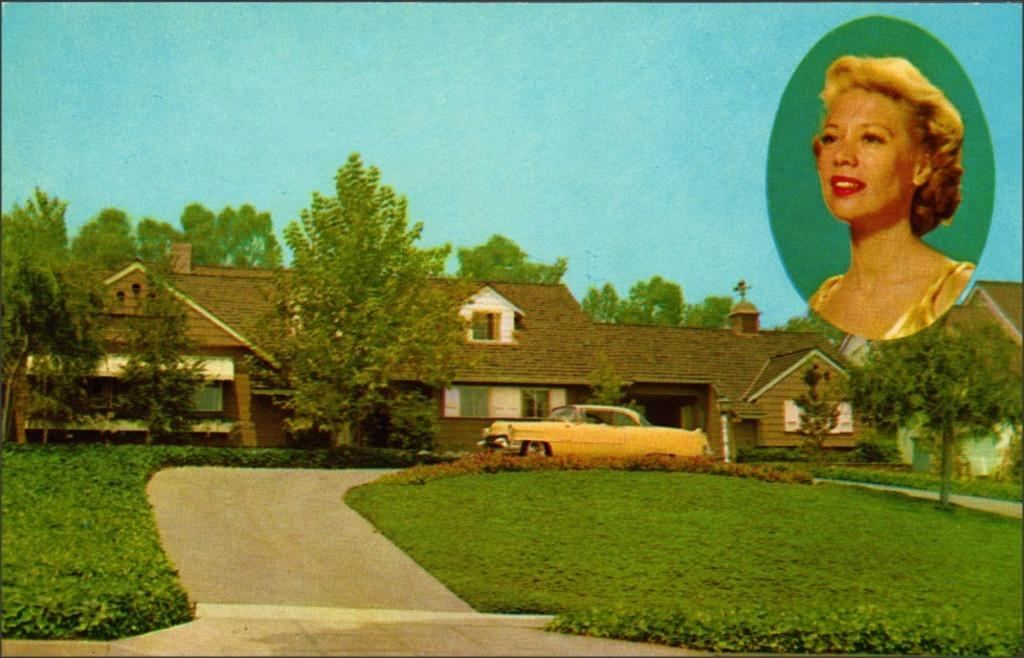What is the main subject of the image? The main subject of the image is a car. What else can be seen in the image besides the car? There is a building, trees, grass, and the sky visible in the image. Is there any indication of a person in the image? Yes, there is a woman's photo in the image. Where is the stove located in the image? There is no stove present in the image. What type of toothpaste is being used by the woman in the photo? There is no toothpaste or indication of a woman using toothpaste in the image, as it only contains a photo of a woman. 